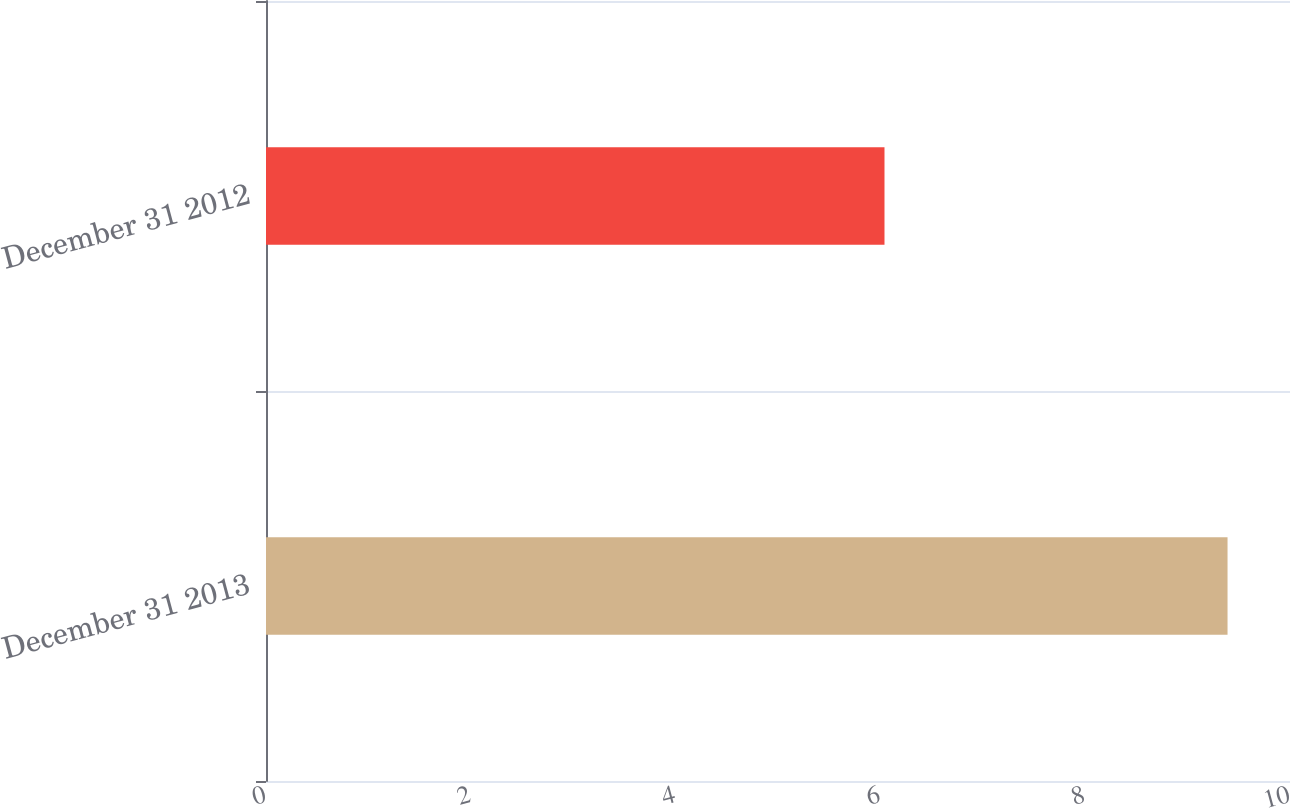Convert chart. <chart><loc_0><loc_0><loc_500><loc_500><bar_chart><fcel>December 31 2013<fcel>December 31 2012<nl><fcel>9.39<fcel>6.04<nl></chart> 